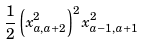<formula> <loc_0><loc_0><loc_500><loc_500>\frac { 1 } { 2 } \left ( x _ { a , a + 2 } ^ { 2 } \right ) ^ { 2 } x _ { a - 1 , a + 1 } ^ { 2 }</formula> 